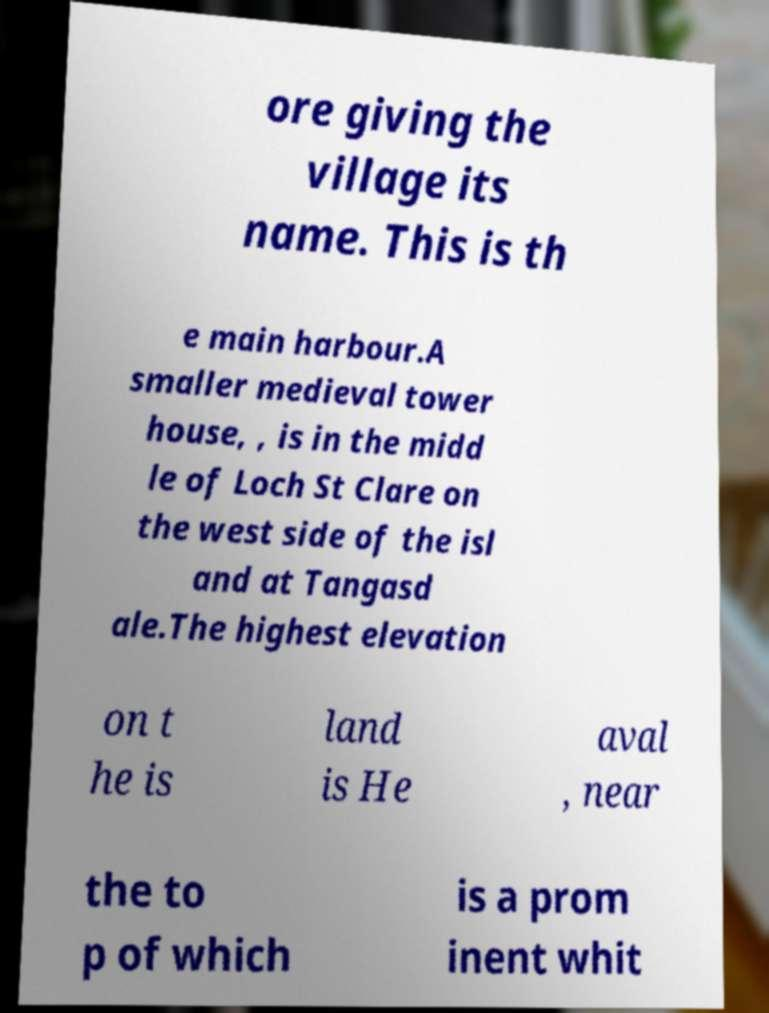Could you assist in decoding the text presented in this image and type it out clearly? ore giving the village its name. This is th e main harbour.A smaller medieval tower house, , is in the midd le of Loch St Clare on the west side of the isl and at Tangasd ale.The highest elevation on t he is land is He aval , near the to p of which is a prom inent whit 